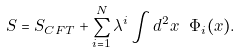<formula> <loc_0><loc_0><loc_500><loc_500>S = S _ { C F T } + \sum _ { i = 1 } ^ { N } \lambda ^ { i } \int d ^ { 2 } x \ \Phi _ { i } ( x ) .</formula> 